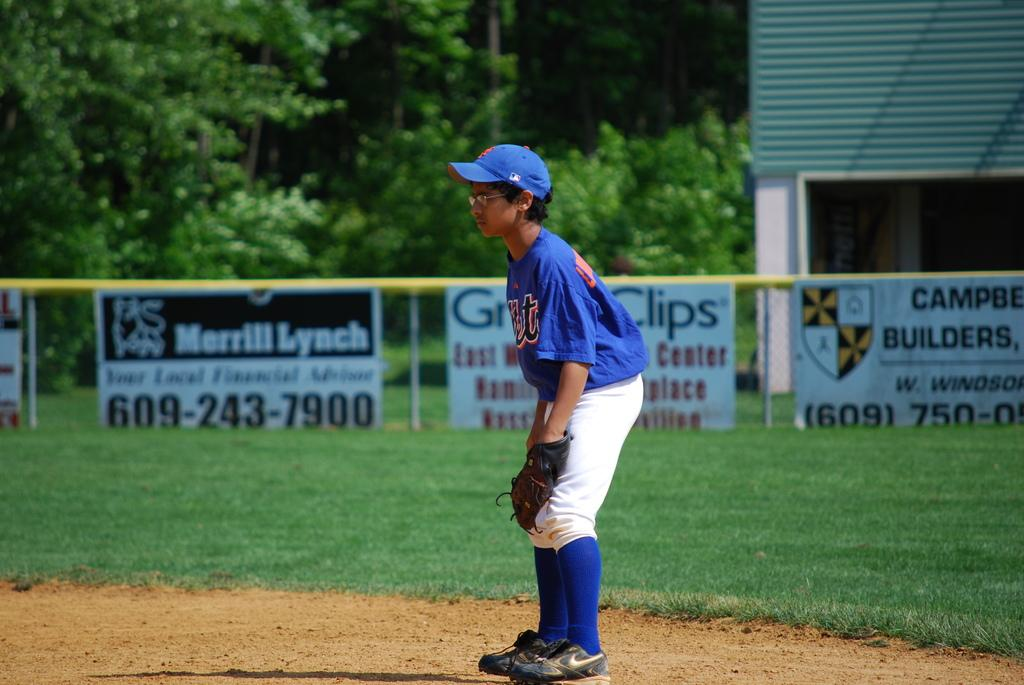Provide a one-sentence caption for the provided image. An ad for Merrill Lynch is hanging against the fence among other ads. 